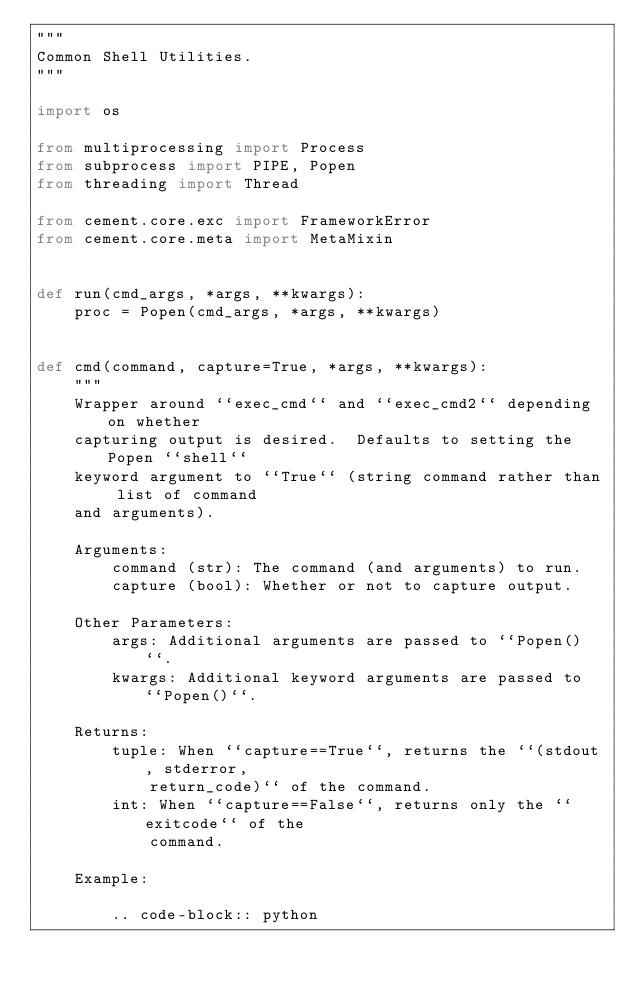<code> <loc_0><loc_0><loc_500><loc_500><_Python_>"""
Common Shell Utilities.
"""

import os

from multiprocessing import Process
from subprocess import PIPE, Popen
from threading import Thread

from cement.core.exc import FrameworkError
from cement.core.meta import MetaMixin


def run(cmd_args, *args, **kwargs):
    proc = Popen(cmd_args, *args, **kwargs)


def cmd(command, capture=True, *args, **kwargs):
    """
    Wrapper around ``exec_cmd`` and ``exec_cmd2`` depending on whether
    capturing output is desired.  Defaults to setting the Popen ``shell``
    keyword argument to ``True`` (string command rather than list of command
    and arguments).

    Arguments:
        command (str): The command (and arguments) to run.
        capture (bool): Whether or not to capture output.

    Other Parameters:
        args: Additional arguments are passed to ``Popen()``.
        kwargs: Additional keyword arguments are passed to ``Popen()``.

    Returns:
        tuple: When ``capture==True``, returns the ``(stdout, stderror,
            return_code)`` of the command.
        int: When ``capture==False``, returns only the ``exitcode`` of the
            command.

    Example:

        .. code-block:: python
</code> 